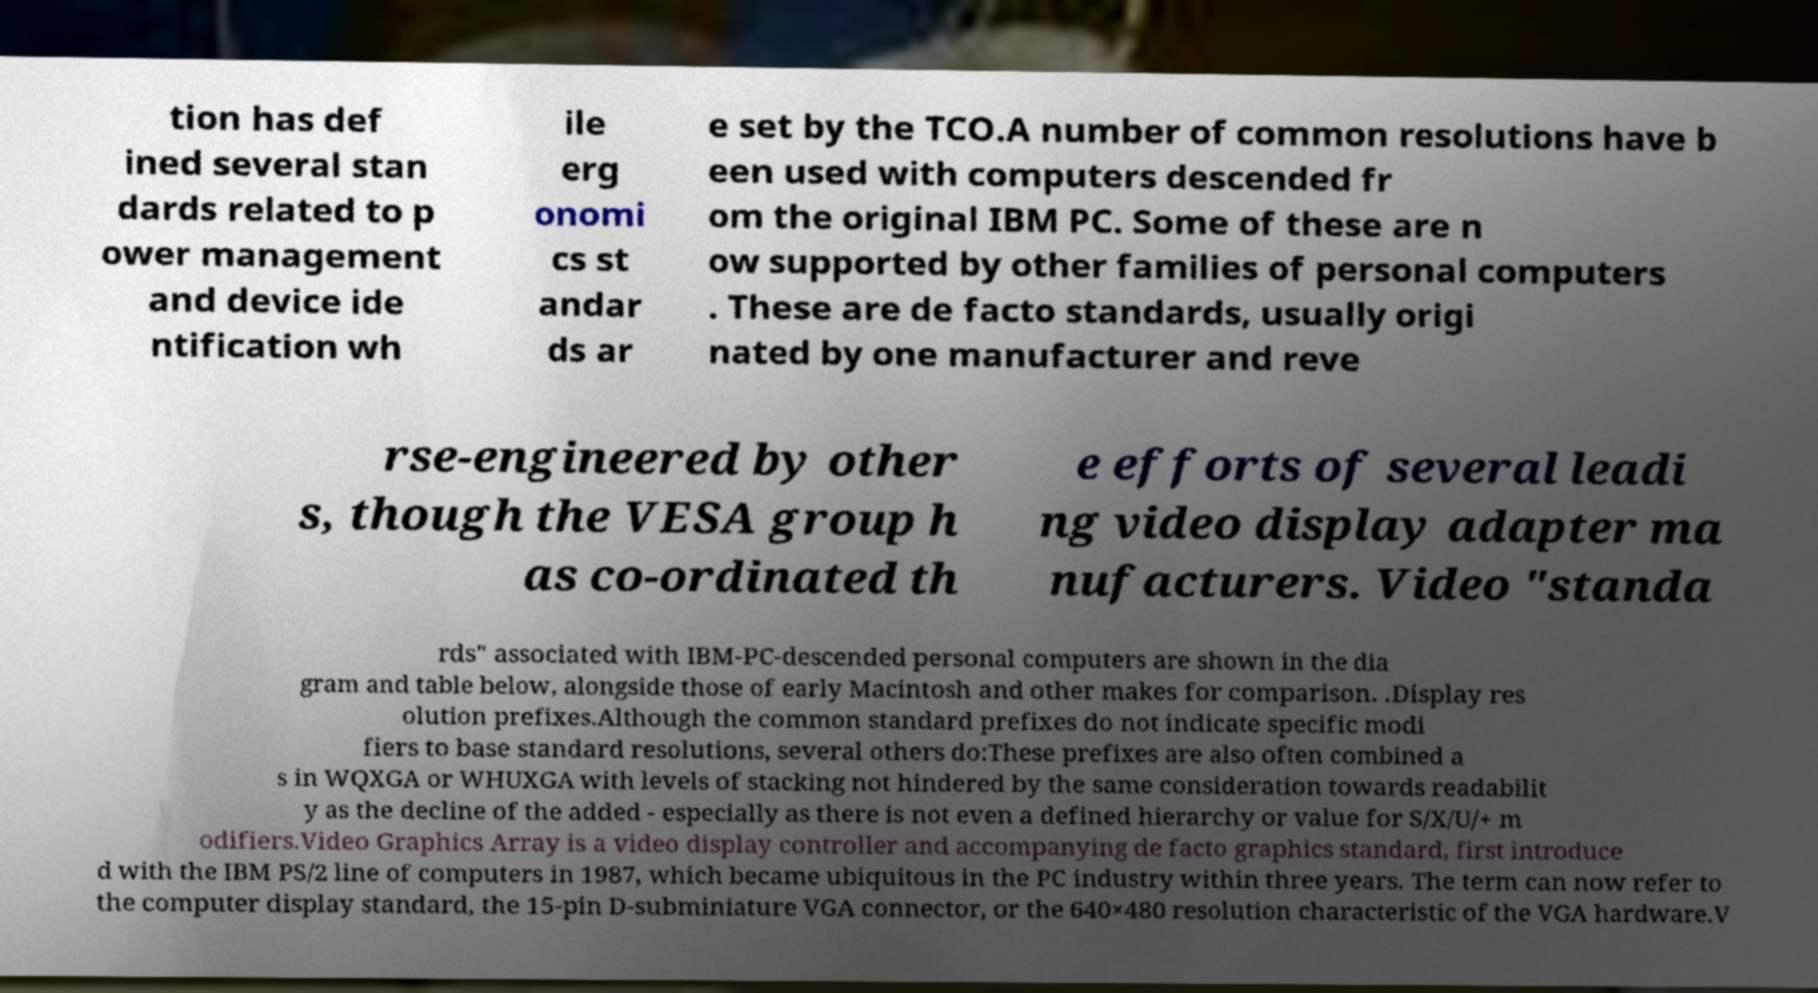Could you extract and type out the text from this image? tion has def ined several stan dards related to p ower management and device ide ntification wh ile erg onomi cs st andar ds ar e set by the TCO.A number of common resolutions have b een used with computers descended fr om the original IBM PC. Some of these are n ow supported by other families of personal computers . These are de facto standards, usually origi nated by one manufacturer and reve rse-engineered by other s, though the VESA group h as co-ordinated th e efforts of several leadi ng video display adapter ma nufacturers. Video "standa rds" associated with IBM-PC-descended personal computers are shown in the dia gram and table below, alongside those of early Macintosh and other makes for comparison. .Display res olution prefixes.Although the common standard prefixes do not indicate specific modi fiers to base standard resolutions, several others do:These prefixes are also often combined a s in WQXGA or WHUXGA with levels of stacking not hindered by the same consideration towards readabilit y as the decline of the added - especially as there is not even a defined hierarchy or value for S/X/U/+ m odifiers.Video Graphics Array is a video display controller and accompanying de facto graphics standard, first introduce d with the IBM PS/2 line of computers in 1987, which became ubiquitous in the PC industry within three years. The term can now refer to the computer display standard, the 15-pin D-subminiature VGA connector, or the 640×480 resolution characteristic of the VGA hardware.V 